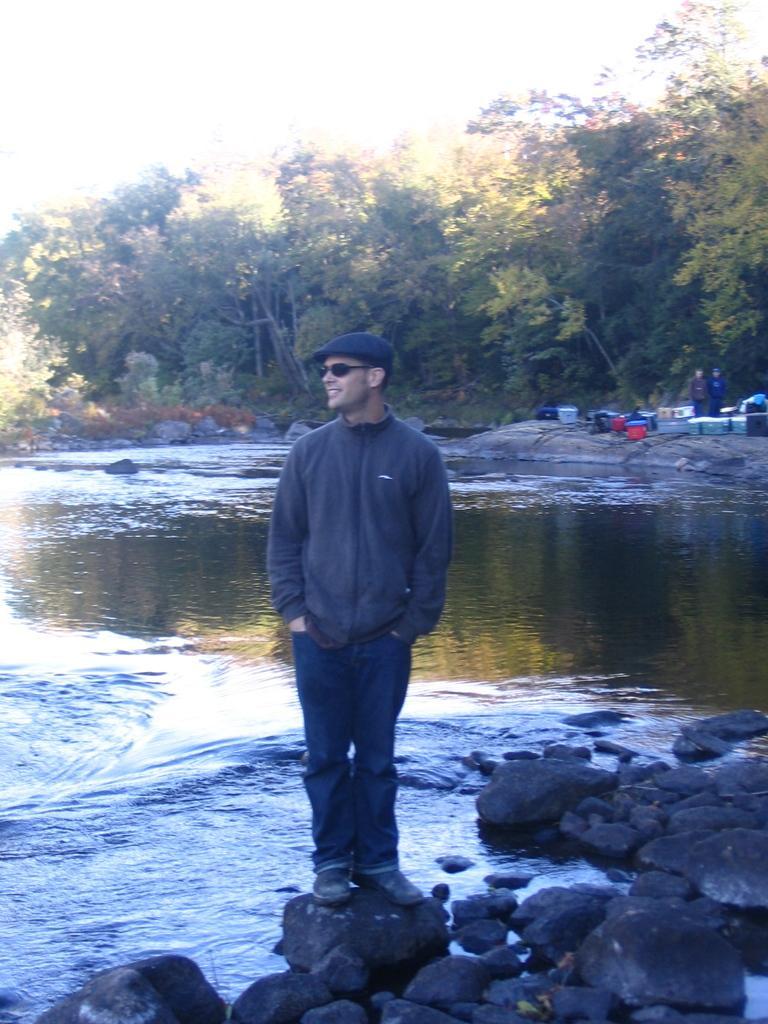In one or two sentences, can you explain what this image depicts? In this picture I can observe a man standing on the stone in the middle of the picture. In the bottom of the picture I can observe stones. Behind him I can observe water. In the background there are trees. 